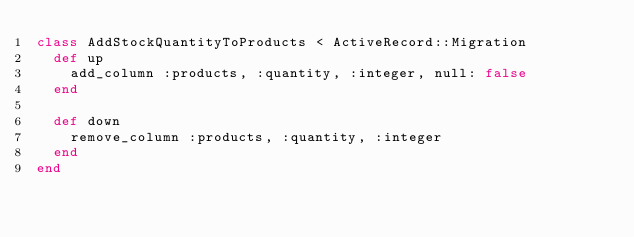<code> <loc_0><loc_0><loc_500><loc_500><_Ruby_>class AddStockQuantityToProducts < ActiveRecord::Migration
  def up
    add_column :products, :quantity, :integer, null: false
  end

  def down
    remove_column :products, :quantity, :integer
  end
end
</code> 